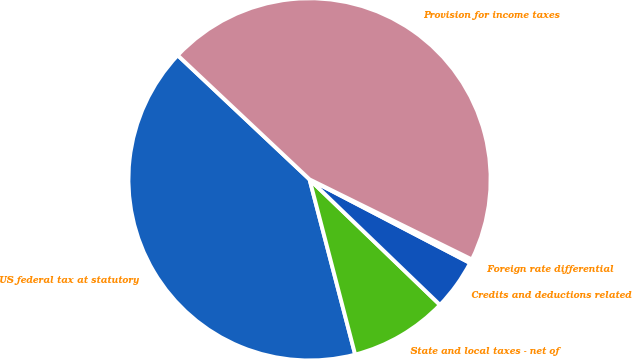<chart> <loc_0><loc_0><loc_500><loc_500><pie_chart><fcel>US federal tax at statutory<fcel>State and local taxes - net of<fcel>Credits and deductions related<fcel>Foreign rate differential<fcel>Provision for income taxes<nl><fcel>41.07%<fcel>8.75%<fcel>4.55%<fcel>0.35%<fcel>45.27%<nl></chart> 